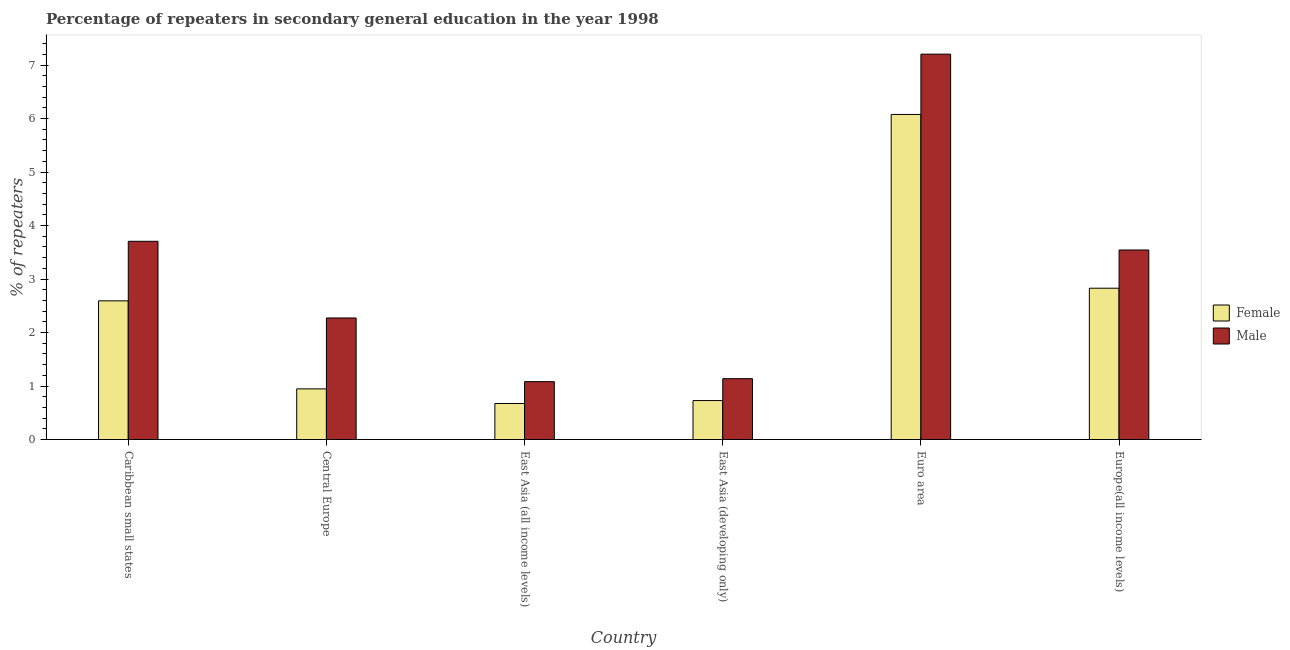How many groups of bars are there?
Your answer should be compact. 6. Are the number of bars on each tick of the X-axis equal?
Offer a terse response. Yes. How many bars are there on the 6th tick from the left?
Your answer should be compact. 2. How many bars are there on the 4th tick from the right?
Provide a short and direct response. 2. What is the label of the 2nd group of bars from the left?
Provide a short and direct response. Central Europe. In how many cases, is the number of bars for a given country not equal to the number of legend labels?
Provide a succinct answer. 0. What is the percentage of male repeaters in Europe(all income levels)?
Offer a very short reply. 3.54. Across all countries, what is the maximum percentage of female repeaters?
Offer a very short reply. 6.08. Across all countries, what is the minimum percentage of female repeaters?
Give a very brief answer. 0.67. In which country was the percentage of male repeaters minimum?
Ensure brevity in your answer.  East Asia (all income levels). What is the total percentage of female repeaters in the graph?
Offer a terse response. 13.85. What is the difference between the percentage of male repeaters in East Asia (developing only) and that in Euro area?
Give a very brief answer. -6.07. What is the difference between the percentage of female repeaters in East Asia (all income levels) and the percentage of male repeaters in Central Europe?
Provide a succinct answer. -1.6. What is the average percentage of male repeaters per country?
Make the answer very short. 3.16. What is the difference between the percentage of male repeaters and percentage of female repeaters in Euro area?
Offer a terse response. 1.13. What is the ratio of the percentage of male repeaters in Central Europe to that in East Asia (all income levels)?
Provide a succinct answer. 2.1. Is the difference between the percentage of female repeaters in Central Europe and Euro area greater than the difference between the percentage of male repeaters in Central Europe and Euro area?
Your answer should be very brief. No. What is the difference between the highest and the second highest percentage of male repeaters?
Your response must be concise. 3.5. What is the difference between the highest and the lowest percentage of female repeaters?
Make the answer very short. 5.4. In how many countries, is the percentage of male repeaters greater than the average percentage of male repeaters taken over all countries?
Your answer should be compact. 3. Is the sum of the percentage of female repeaters in Central Europe and East Asia (all income levels) greater than the maximum percentage of male repeaters across all countries?
Your answer should be very brief. No. What does the 2nd bar from the left in Central Europe represents?
Give a very brief answer. Male. Are all the bars in the graph horizontal?
Ensure brevity in your answer.  No. Where does the legend appear in the graph?
Your response must be concise. Center right. How are the legend labels stacked?
Offer a terse response. Vertical. What is the title of the graph?
Your response must be concise. Percentage of repeaters in secondary general education in the year 1998. What is the label or title of the Y-axis?
Provide a succinct answer. % of repeaters. What is the % of repeaters in Female in Caribbean small states?
Give a very brief answer. 2.59. What is the % of repeaters of Male in Caribbean small states?
Your answer should be very brief. 3.71. What is the % of repeaters of Female in Central Europe?
Your answer should be compact. 0.95. What is the % of repeaters of Male in Central Europe?
Provide a short and direct response. 2.27. What is the % of repeaters of Female in East Asia (all income levels)?
Your response must be concise. 0.67. What is the % of repeaters of Male in East Asia (all income levels)?
Give a very brief answer. 1.08. What is the % of repeaters in Female in East Asia (developing only)?
Keep it short and to the point. 0.73. What is the % of repeaters in Male in East Asia (developing only)?
Give a very brief answer. 1.14. What is the % of repeaters in Female in Euro area?
Keep it short and to the point. 6.08. What is the % of repeaters in Male in Euro area?
Give a very brief answer. 7.2. What is the % of repeaters of Female in Europe(all income levels)?
Your response must be concise. 2.83. What is the % of repeaters of Male in Europe(all income levels)?
Give a very brief answer. 3.54. Across all countries, what is the maximum % of repeaters in Female?
Provide a succinct answer. 6.08. Across all countries, what is the maximum % of repeaters in Male?
Offer a very short reply. 7.2. Across all countries, what is the minimum % of repeaters of Female?
Offer a very short reply. 0.67. Across all countries, what is the minimum % of repeaters in Male?
Provide a short and direct response. 1.08. What is the total % of repeaters of Female in the graph?
Offer a very short reply. 13.85. What is the total % of repeaters in Male in the graph?
Your answer should be very brief. 18.95. What is the difference between the % of repeaters of Female in Caribbean small states and that in Central Europe?
Your answer should be very brief. 1.65. What is the difference between the % of repeaters of Male in Caribbean small states and that in Central Europe?
Offer a terse response. 1.43. What is the difference between the % of repeaters of Female in Caribbean small states and that in East Asia (all income levels)?
Offer a terse response. 1.92. What is the difference between the % of repeaters in Male in Caribbean small states and that in East Asia (all income levels)?
Provide a succinct answer. 2.62. What is the difference between the % of repeaters of Female in Caribbean small states and that in East Asia (developing only)?
Provide a succinct answer. 1.86. What is the difference between the % of repeaters in Male in Caribbean small states and that in East Asia (developing only)?
Make the answer very short. 2.57. What is the difference between the % of repeaters of Female in Caribbean small states and that in Euro area?
Your answer should be very brief. -3.48. What is the difference between the % of repeaters in Male in Caribbean small states and that in Euro area?
Offer a terse response. -3.5. What is the difference between the % of repeaters in Female in Caribbean small states and that in Europe(all income levels)?
Keep it short and to the point. -0.24. What is the difference between the % of repeaters in Male in Caribbean small states and that in Europe(all income levels)?
Your response must be concise. 0.16. What is the difference between the % of repeaters in Female in Central Europe and that in East Asia (all income levels)?
Your answer should be very brief. 0.27. What is the difference between the % of repeaters of Male in Central Europe and that in East Asia (all income levels)?
Your response must be concise. 1.19. What is the difference between the % of repeaters of Female in Central Europe and that in East Asia (developing only)?
Your answer should be compact. 0.22. What is the difference between the % of repeaters in Male in Central Europe and that in East Asia (developing only)?
Your answer should be compact. 1.14. What is the difference between the % of repeaters in Female in Central Europe and that in Euro area?
Give a very brief answer. -5.13. What is the difference between the % of repeaters in Male in Central Europe and that in Euro area?
Offer a very short reply. -4.93. What is the difference between the % of repeaters in Female in Central Europe and that in Europe(all income levels)?
Your answer should be very brief. -1.88. What is the difference between the % of repeaters of Male in Central Europe and that in Europe(all income levels)?
Offer a terse response. -1.27. What is the difference between the % of repeaters of Female in East Asia (all income levels) and that in East Asia (developing only)?
Make the answer very short. -0.05. What is the difference between the % of repeaters of Male in East Asia (all income levels) and that in East Asia (developing only)?
Your answer should be very brief. -0.06. What is the difference between the % of repeaters of Female in East Asia (all income levels) and that in Euro area?
Give a very brief answer. -5.4. What is the difference between the % of repeaters of Male in East Asia (all income levels) and that in Euro area?
Provide a succinct answer. -6.12. What is the difference between the % of repeaters in Female in East Asia (all income levels) and that in Europe(all income levels)?
Provide a short and direct response. -2.16. What is the difference between the % of repeaters of Male in East Asia (all income levels) and that in Europe(all income levels)?
Make the answer very short. -2.46. What is the difference between the % of repeaters of Female in East Asia (developing only) and that in Euro area?
Offer a very short reply. -5.35. What is the difference between the % of repeaters of Male in East Asia (developing only) and that in Euro area?
Your answer should be compact. -6.07. What is the difference between the % of repeaters in Female in East Asia (developing only) and that in Europe(all income levels)?
Give a very brief answer. -2.1. What is the difference between the % of repeaters of Male in East Asia (developing only) and that in Europe(all income levels)?
Your answer should be very brief. -2.41. What is the difference between the % of repeaters of Female in Euro area and that in Europe(all income levels)?
Your answer should be very brief. 3.25. What is the difference between the % of repeaters in Male in Euro area and that in Europe(all income levels)?
Provide a succinct answer. 3.66. What is the difference between the % of repeaters of Female in Caribbean small states and the % of repeaters of Male in Central Europe?
Your response must be concise. 0.32. What is the difference between the % of repeaters of Female in Caribbean small states and the % of repeaters of Male in East Asia (all income levels)?
Offer a very short reply. 1.51. What is the difference between the % of repeaters in Female in Caribbean small states and the % of repeaters in Male in East Asia (developing only)?
Your answer should be very brief. 1.46. What is the difference between the % of repeaters in Female in Caribbean small states and the % of repeaters in Male in Euro area?
Offer a terse response. -4.61. What is the difference between the % of repeaters of Female in Caribbean small states and the % of repeaters of Male in Europe(all income levels)?
Offer a very short reply. -0.95. What is the difference between the % of repeaters of Female in Central Europe and the % of repeaters of Male in East Asia (all income levels)?
Your answer should be compact. -0.14. What is the difference between the % of repeaters of Female in Central Europe and the % of repeaters of Male in East Asia (developing only)?
Your answer should be compact. -0.19. What is the difference between the % of repeaters of Female in Central Europe and the % of repeaters of Male in Euro area?
Ensure brevity in your answer.  -6.26. What is the difference between the % of repeaters in Female in Central Europe and the % of repeaters in Male in Europe(all income levels)?
Provide a succinct answer. -2.6. What is the difference between the % of repeaters of Female in East Asia (all income levels) and the % of repeaters of Male in East Asia (developing only)?
Your answer should be compact. -0.46. What is the difference between the % of repeaters of Female in East Asia (all income levels) and the % of repeaters of Male in Euro area?
Offer a terse response. -6.53. What is the difference between the % of repeaters of Female in East Asia (all income levels) and the % of repeaters of Male in Europe(all income levels)?
Your answer should be very brief. -2.87. What is the difference between the % of repeaters in Female in East Asia (developing only) and the % of repeaters in Male in Euro area?
Your answer should be very brief. -6.48. What is the difference between the % of repeaters in Female in East Asia (developing only) and the % of repeaters in Male in Europe(all income levels)?
Ensure brevity in your answer.  -2.82. What is the difference between the % of repeaters of Female in Euro area and the % of repeaters of Male in Europe(all income levels)?
Your answer should be very brief. 2.53. What is the average % of repeaters of Female per country?
Offer a terse response. 2.31. What is the average % of repeaters in Male per country?
Your answer should be very brief. 3.16. What is the difference between the % of repeaters in Female and % of repeaters in Male in Caribbean small states?
Your answer should be very brief. -1.11. What is the difference between the % of repeaters in Female and % of repeaters in Male in Central Europe?
Make the answer very short. -1.33. What is the difference between the % of repeaters in Female and % of repeaters in Male in East Asia (all income levels)?
Ensure brevity in your answer.  -0.41. What is the difference between the % of repeaters in Female and % of repeaters in Male in East Asia (developing only)?
Your response must be concise. -0.41. What is the difference between the % of repeaters of Female and % of repeaters of Male in Euro area?
Offer a terse response. -1.13. What is the difference between the % of repeaters in Female and % of repeaters in Male in Europe(all income levels)?
Ensure brevity in your answer.  -0.71. What is the ratio of the % of repeaters of Female in Caribbean small states to that in Central Europe?
Your response must be concise. 2.74. What is the ratio of the % of repeaters in Male in Caribbean small states to that in Central Europe?
Provide a short and direct response. 1.63. What is the ratio of the % of repeaters in Female in Caribbean small states to that in East Asia (all income levels)?
Your response must be concise. 3.85. What is the ratio of the % of repeaters in Male in Caribbean small states to that in East Asia (all income levels)?
Keep it short and to the point. 3.43. What is the ratio of the % of repeaters in Female in Caribbean small states to that in East Asia (developing only)?
Keep it short and to the point. 3.56. What is the ratio of the % of repeaters in Male in Caribbean small states to that in East Asia (developing only)?
Ensure brevity in your answer.  3.26. What is the ratio of the % of repeaters in Female in Caribbean small states to that in Euro area?
Offer a terse response. 0.43. What is the ratio of the % of repeaters in Male in Caribbean small states to that in Euro area?
Give a very brief answer. 0.51. What is the ratio of the % of repeaters of Female in Caribbean small states to that in Europe(all income levels)?
Provide a succinct answer. 0.92. What is the ratio of the % of repeaters of Male in Caribbean small states to that in Europe(all income levels)?
Your answer should be very brief. 1.05. What is the ratio of the % of repeaters in Female in Central Europe to that in East Asia (all income levels)?
Your answer should be compact. 1.41. What is the ratio of the % of repeaters of Male in Central Europe to that in East Asia (all income levels)?
Offer a terse response. 2.1. What is the ratio of the % of repeaters of Female in Central Europe to that in East Asia (developing only)?
Your response must be concise. 1.3. What is the ratio of the % of repeaters in Male in Central Europe to that in East Asia (developing only)?
Provide a short and direct response. 2. What is the ratio of the % of repeaters in Female in Central Europe to that in Euro area?
Ensure brevity in your answer.  0.16. What is the ratio of the % of repeaters in Male in Central Europe to that in Euro area?
Your answer should be compact. 0.32. What is the ratio of the % of repeaters in Female in Central Europe to that in Europe(all income levels)?
Your response must be concise. 0.33. What is the ratio of the % of repeaters in Male in Central Europe to that in Europe(all income levels)?
Keep it short and to the point. 0.64. What is the ratio of the % of repeaters of Female in East Asia (all income levels) to that in East Asia (developing only)?
Your answer should be compact. 0.92. What is the ratio of the % of repeaters in Male in East Asia (all income levels) to that in East Asia (developing only)?
Give a very brief answer. 0.95. What is the ratio of the % of repeaters in Female in East Asia (all income levels) to that in Euro area?
Your response must be concise. 0.11. What is the ratio of the % of repeaters of Male in East Asia (all income levels) to that in Euro area?
Provide a succinct answer. 0.15. What is the ratio of the % of repeaters in Female in East Asia (all income levels) to that in Europe(all income levels)?
Provide a succinct answer. 0.24. What is the ratio of the % of repeaters of Male in East Asia (all income levels) to that in Europe(all income levels)?
Keep it short and to the point. 0.31. What is the ratio of the % of repeaters of Female in East Asia (developing only) to that in Euro area?
Your response must be concise. 0.12. What is the ratio of the % of repeaters of Male in East Asia (developing only) to that in Euro area?
Ensure brevity in your answer.  0.16. What is the ratio of the % of repeaters in Female in East Asia (developing only) to that in Europe(all income levels)?
Make the answer very short. 0.26. What is the ratio of the % of repeaters of Male in East Asia (developing only) to that in Europe(all income levels)?
Keep it short and to the point. 0.32. What is the ratio of the % of repeaters of Female in Euro area to that in Europe(all income levels)?
Ensure brevity in your answer.  2.15. What is the ratio of the % of repeaters in Male in Euro area to that in Europe(all income levels)?
Your answer should be very brief. 2.03. What is the difference between the highest and the second highest % of repeaters of Female?
Provide a succinct answer. 3.25. What is the difference between the highest and the second highest % of repeaters of Male?
Your answer should be compact. 3.5. What is the difference between the highest and the lowest % of repeaters of Female?
Make the answer very short. 5.4. What is the difference between the highest and the lowest % of repeaters in Male?
Your answer should be compact. 6.12. 